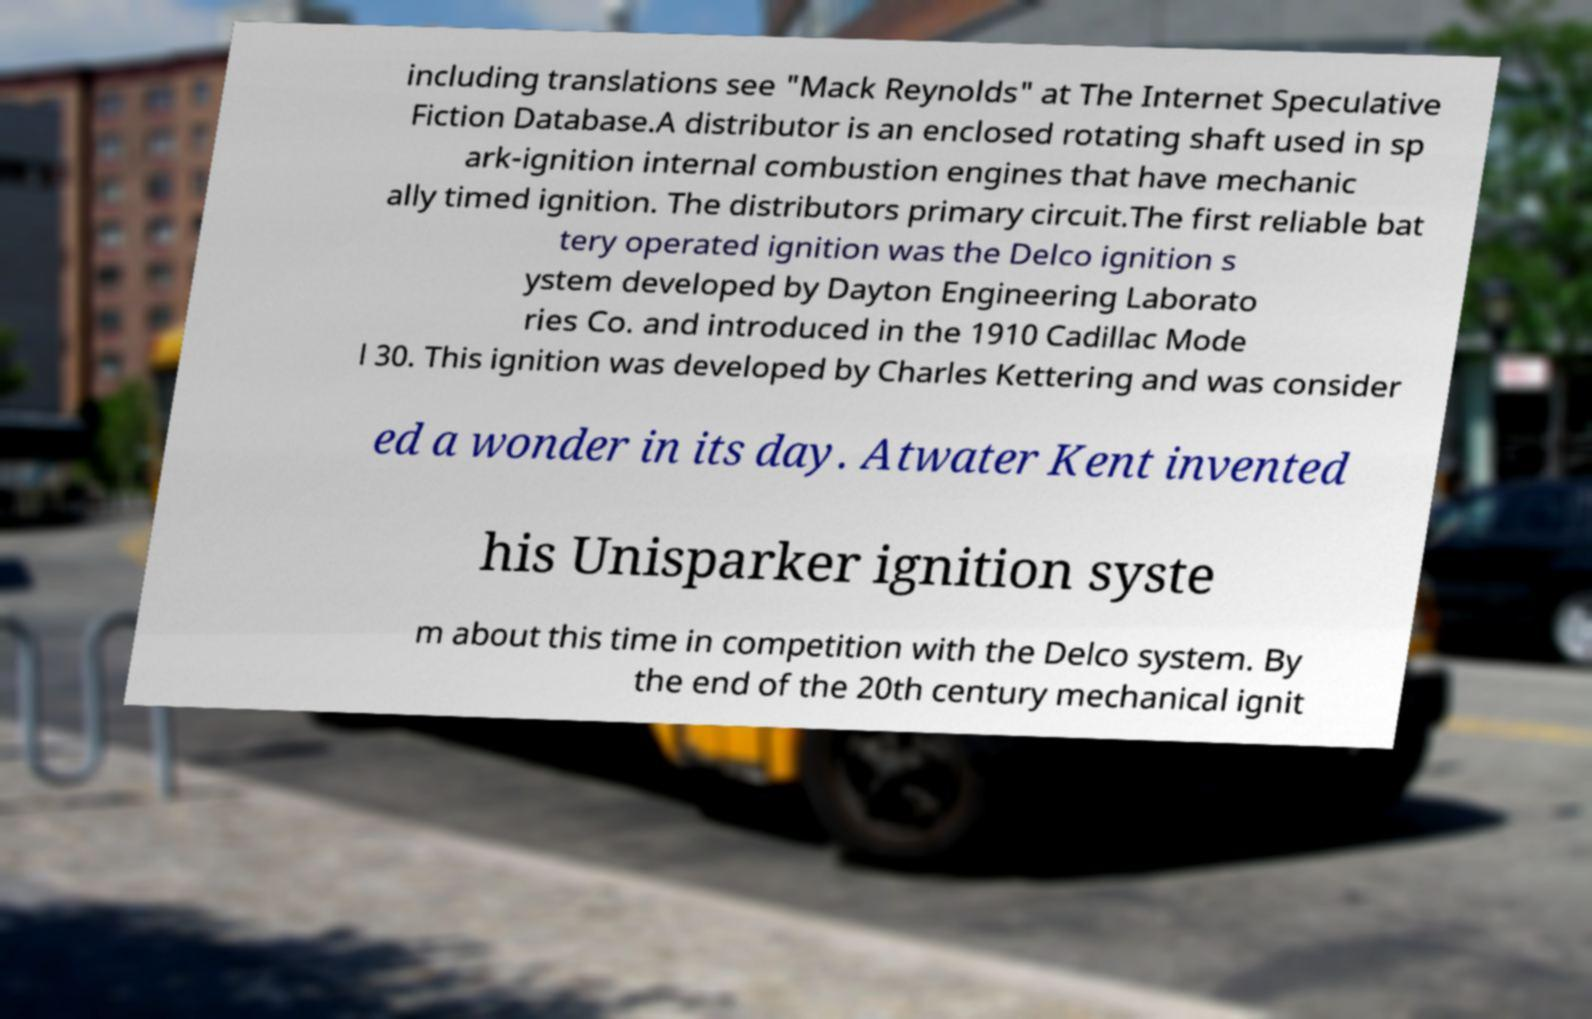Could you extract and type out the text from this image? including translations see "Mack Reynolds" at The Internet Speculative Fiction Database.A distributor is an enclosed rotating shaft used in sp ark-ignition internal combustion engines that have mechanic ally timed ignition. The distributors primary circuit.The first reliable bat tery operated ignition was the Delco ignition s ystem developed by Dayton Engineering Laborato ries Co. and introduced in the 1910 Cadillac Mode l 30. This ignition was developed by Charles Kettering and was consider ed a wonder in its day. Atwater Kent invented his Unisparker ignition syste m about this time in competition with the Delco system. By the end of the 20th century mechanical ignit 